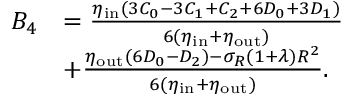<formula> <loc_0><loc_0><loc_500><loc_500>\begin{array} { r l } { B _ { 4 } } & { = \frac { \eta _ { i n } ( 3 C _ { 0 } - 3 C _ { 1 } + C _ { 2 } + 6 D _ { 0 } + 3 D _ { 1 } ) } { 6 ( \eta _ { i n } + \eta _ { o u t } ) } } \\ & { + \frac { \eta _ { o u t } ( 6 D _ { 0 } - D _ { 2 } ) - \sigma _ { R } ( 1 + \lambda ) R ^ { 2 } } { 6 ( \eta _ { i n } + \eta _ { o u t } ) } . } \end{array}</formula> 